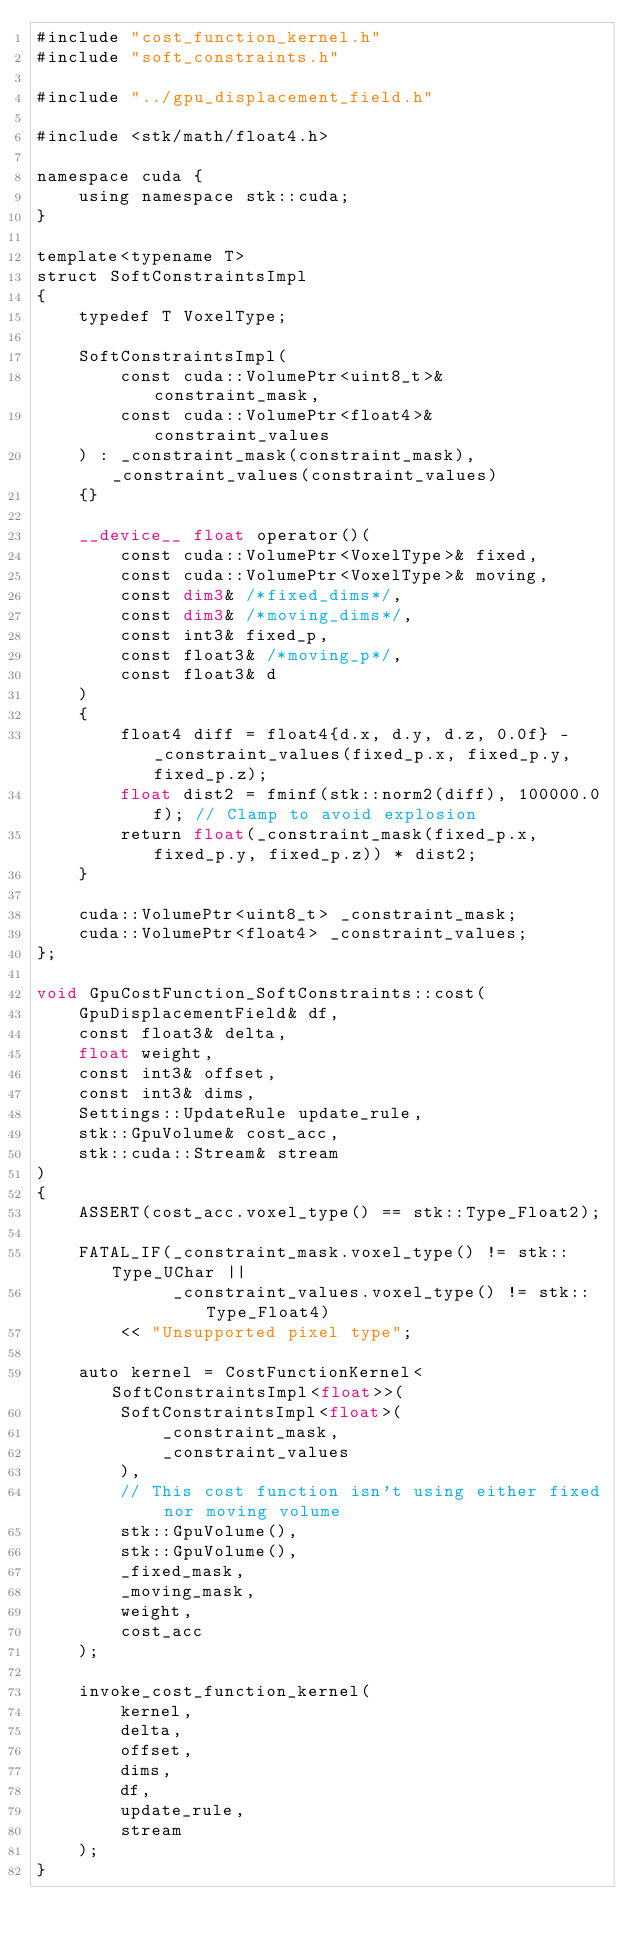Convert code to text. <code><loc_0><loc_0><loc_500><loc_500><_Cuda_>#include "cost_function_kernel.h"
#include "soft_constraints.h"

#include "../gpu_displacement_field.h"

#include <stk/math/float4.h>

namespace cuda {
    using namespace stk::cuda;
}

template<typename T>
struct SoftConstraintsImpl
{
    typedef T VoxelType;

    SoftConstraintsImpl(
        const cuda::VolumePtr<uint8_t>& constraint_mask,
        const cuda::VolumePtr<float4>& constraint_values
    ) : _constraint_mask(constraint_mask), _constraint_values(constraint_values)
    {}

    __device__ float operator()(
        const cuda::VolumePtr<VoxelType>& fixed,
        const cuda::VolumePtr<VoxelType>& moving,
        const dim3& /*fixed_dims*/,
        const dim3& /*moving_dims*/,
        const int3& fixed_p,
        const float3& /*moving_p*/,
        const float3& d
    )
    {
        float4 diff = float4{d.x, d.y, d.z, 0.0f} - _constraint_values(fixed_p.x, fixed_p.y, fixed_p.z);
        float dist2 = fminf(stk::norm2(diff), 100000.0f); // Clamp to avoid explosion
        return float(_constraint_mask(fixed_p.x, fixed_p.y, fixed_p.z)) * dist2;
    }

    cuda::VolumePtr<uint8_t> _constraint_mask;
    cuda::VolumePtr<float4> _constraint_values;
};

void GpuCostFunction_SoftConstraints::cost(
    GpuDisplacementField& df,
    const float3& delta,
    float weight,
    const int3& offset,
    const int3& dims,
    Settings::UpdateRule update_rule,
    stk::GpuVolume& cost_acc,
    stk::cuda::Stream& stream
)
{
    ASSERT(cost_acc.voxel_type() == stk::Type_Float2);

    FATAL_IF(_constraint_mask.voxel_type() != stk::Type_UChar ||
             _constraint_values.voxel_type() != stk::Type_Float4)
        << "Unsupported pixel type";

    auto kernel = CostFunctionKernel<SoftConstraintsImpl<float>>(
        SoftConstraintsImpl<float>(
            _constraint_mask,
            _constraint_values
        ),
        // This cost function isn't using either fixed nor moving volume
        stk::GpuVolume(),
        stk::GpuVolume(),
        _fixed_mask,
        _moving_mask,
        weight,
        cost_acc
    );

    invoke_cost_function_kernel(
        kernel,
        delta,
        offset,
        dims,
        df,
        update_rule,
        stream
    );
}

</code> 